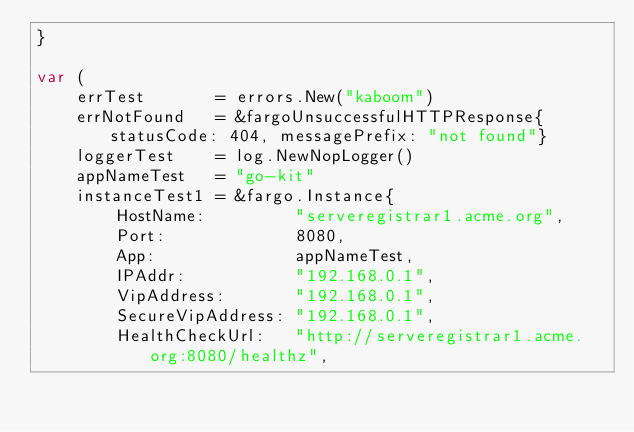Convert code to text. <code><loc_0><loc_0><loc_500><loc_500><_Go_>}

var (
	errTest       = errors.New("kaboom")
	errNotFound   = &fargoUnsuccessfulHTTPResponse{statusCode: 404, messagePrefix: "not found"}
	loggerTest    = log.NewNopLogger()
	appNameTest   = "go-kit"
	instanceTest1 = &fargo.Instance{
		HostName:         "serveregistrar1.acme.org",
		Port:             8080,
		App:              appNameTest,
		IPAddr:           "192.168.0.1",
		VipAddress:       "192.168.0.1",
		SecureVipAddress: "192.168.0.1",
		HealthCheckUrl:   "http://serveregistrar1.acme.org:8080/healthz",</code> 